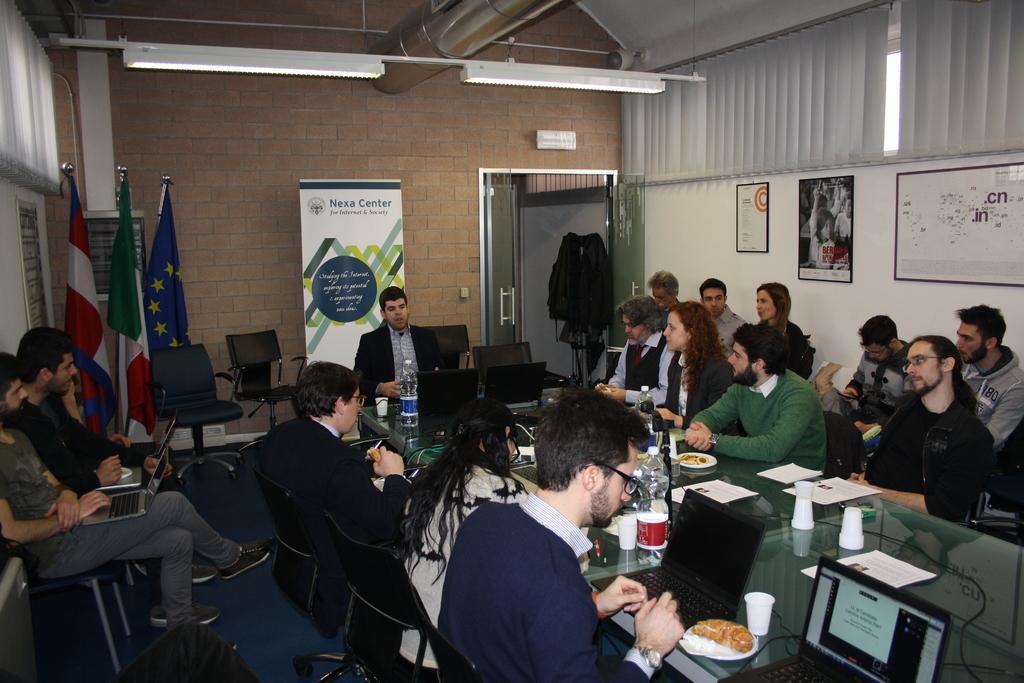In one or two sentences, can you explain what this image depicts? In this image we can see there are a few people sitting on chairs, in front of them there is a table. On the table there are laptops, good items on a plate, disposal glasses, bottles and some papers. On the left side of the image there are three flags, beside that there are the other two people sitting on a chair and holding their laptops. In the background there is a wall. 